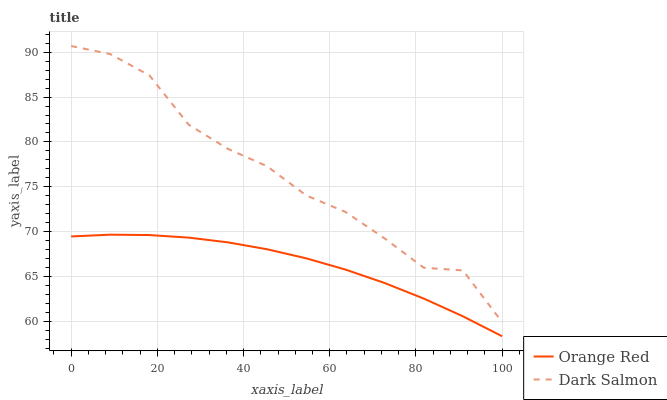Does Orange Red have the minimum area under the curve?
Answer yes or no. Yes. Does Dark Salmon have the maximum area under the curve?
Answer yes or no. Yes. Does Dark Salmon have the minimum area under the curve?
Answer yes or no. No. Is Orange Red the smoothest?
Answer yes or no. Yes. Is Dark Salmon the roughest?
Answer yes or no. Yes. Is Dark Salmon the smoothest?
Answer yes or no. No. Does Orange Red have the lowest value?
Answer yes or no. Yes. Does Dark Salmon have the lowest value?
Answer yes or no. No. Does Dark Salmon have the highest value?
Answer yes or no. Yes. Is Orange Red less than Dark Salmon?
Answer yes or no. Yes. Is Dark Salmon greater than Orange Red?
Answer yes or no. Yes. Does Orange Red intersect Dark Salmon?
Answer yes or no. No. 